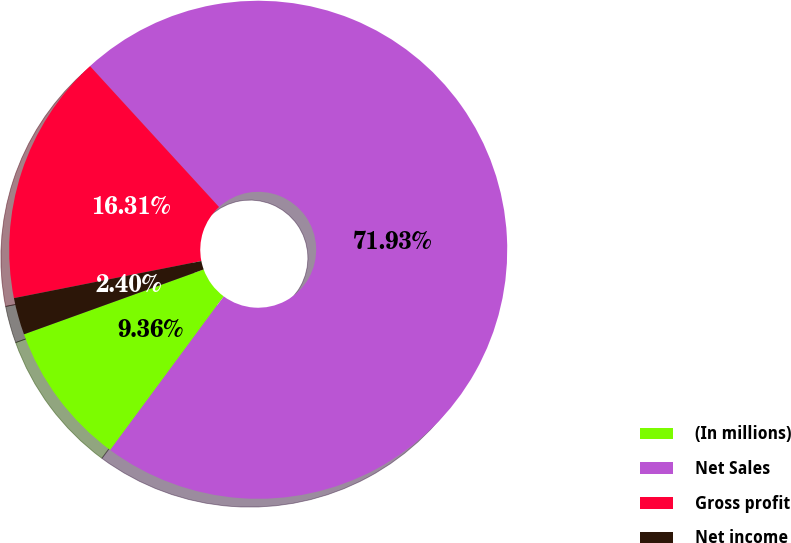Convert chart to OTSL. <chart><loc_0><loc_0><loc_500><loc_500><pie_chart><fcel>(In millions)<fcel>Net Sales<fcel>Gross profit<fcel>Net income<nl><fcel>9.36%<fcel>71.93%<fcel>16.31%<fcel>2.4%<nl></chart> 